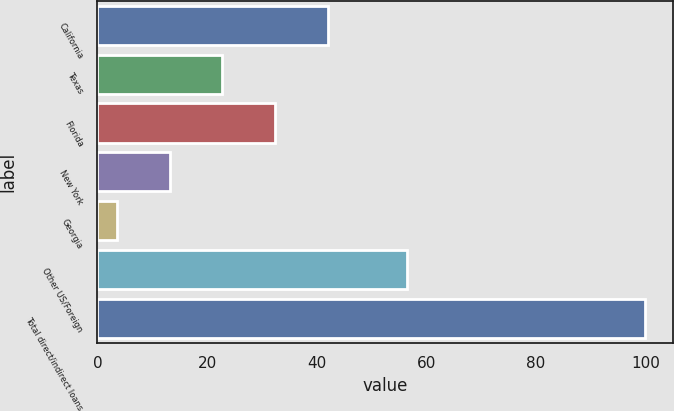Convert chart to OTSL. <chart><loc_0><loc_0><loc_500><loc_500><bar_chart><fcel>California<fcel>Texas<fcel>Florida<fcel>New York<fcel>Georgia<fcel>Other US/Foreign<fcel>Total direct/indirect loans<nl><fcel>42.1<fcel>22.8<fcel>32.45<fcel>13.15<fcel>3.5<fcel>56.5<fcel>100<nl></chart> 